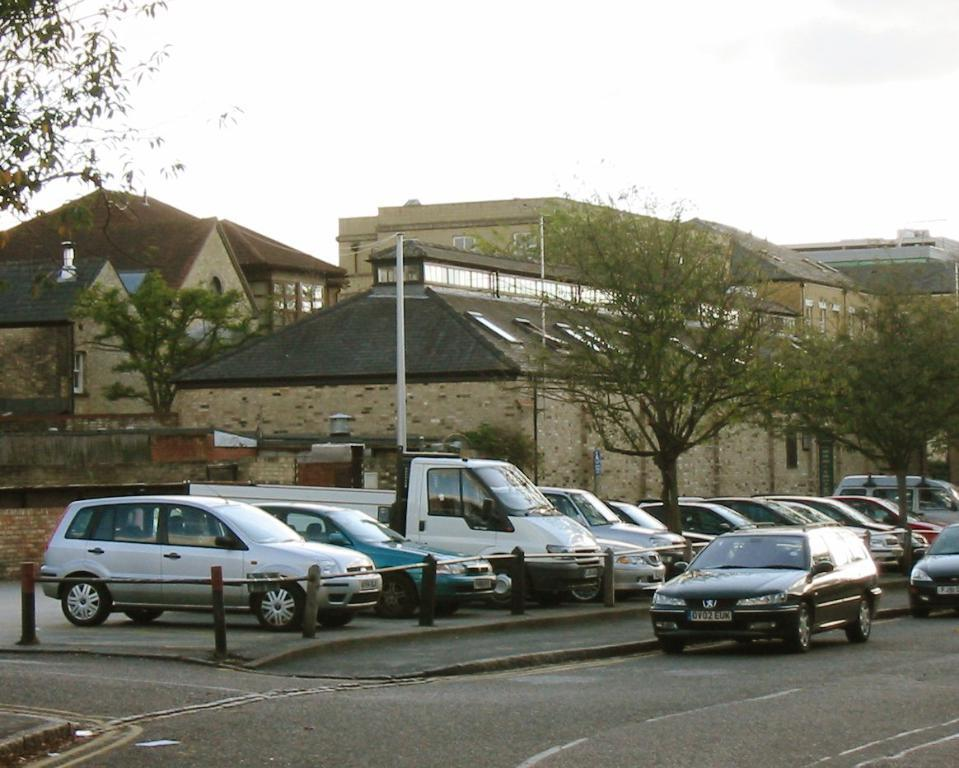What can be seen on the road in the image? There are vehicles on the road in the image. What type of barrier is present in the image? There is a fence in the image. What structures are present in the image? There are poles and houses in the image. What type of vegetation is visible in the image? There are trees in the image. What is visible in the background of the image? The sky is visible in the background of the image. Where are the children playing in the image? There are no children present in the image. What type of animal can be seen interacting with the trees in the image? There are no animals present in the image; only trees, houses, poles, a fence, vehicles, and the sky are visible. 